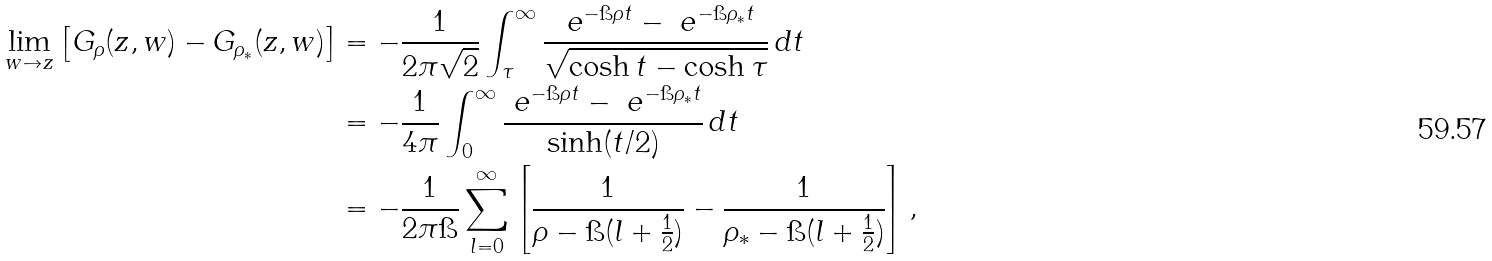Convert formula to latex. <formula><loc_0><loc_0><loc_500><loc_500>\lim _ { w \to z } \left [ G _ { \rho } ( z , w ) - G _ { \rho _ { * } } ( z , w ) \right ] & = - \frac { 1 } { 2 \pi \sqrt { 2 } } \int _ { \tau } ^ { \infty } \frac { \ e ^ { - \i \rho t } - \ e ^ { - \i \rho _ { * } t } } { \sqrt { \cosh t - \cosh \tau } } \, d t \\ & = - \frac { 1 } { 4 \pi } \int _ { 0 } ^ { \infty } \frac { \ e ^ { - \i \rho t } - \ e ^ { - \i \rho _ { * } t } } { \sinh ( t / 2 ) } \, d t \\ & = - \frac { 1 } { 2 \pi \i } \sum _ { l = 0 } ^ { \infty } \left [ \frac { 1 } { \rho - \i ( l + \frac { 1 } { 2 } ) } - \frac { 1 } { \rho _ { * } - \i ( l + \frac { 1 } { 2 } ) } \right ] ,</formula> 